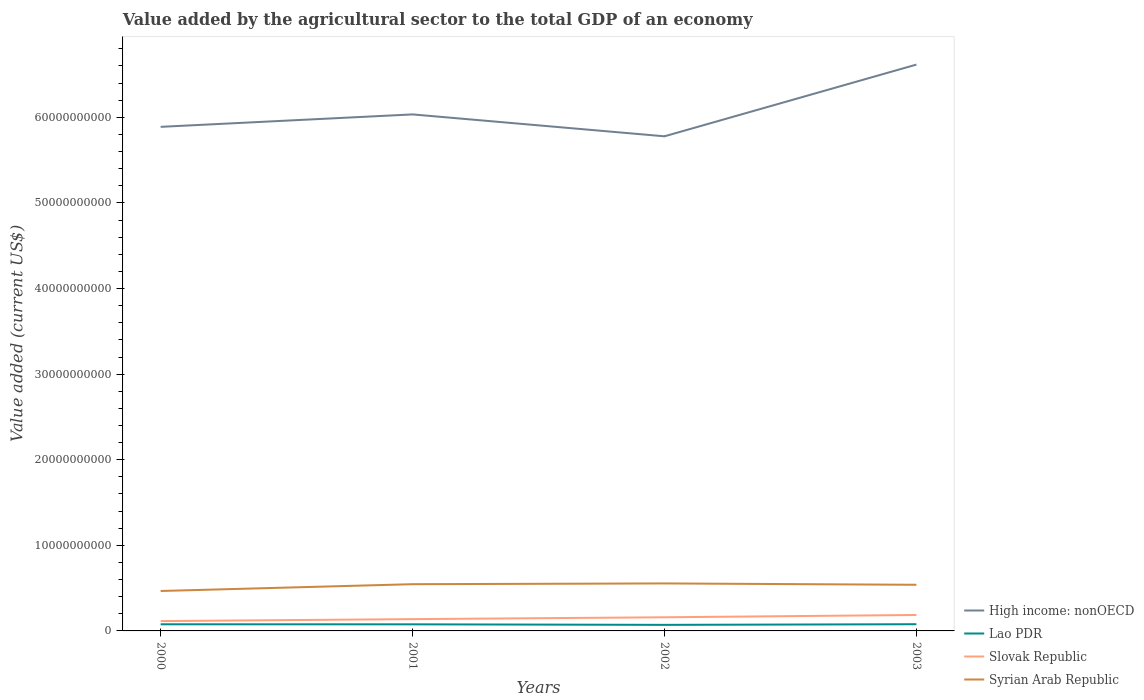Is the number of lines equal to the number of legend labels?
Provide a succinct answer. Yes. Across all years, what is the maximum value added by the agricultural sector to the total GDP in Syrian Arab Republic?
Offer a terse response. 4.67e+09. In which year was the value added by the agricultural sector to the total GDP in Syrian Arab Republic maximum?
Offer a very short reply. 2000. What is the total value added by the agricultural sector to the total GDP in Syrian Arab Republic in the graph?
Your answer should be very brief. -7.94e+08. What is the difference between the highest and the second highest value added by the agricultural sector to the total GDP in Syrian Arab Republic?
Provide a succinct answer. 8.83e+08. How many lines are there?
Offer a very short reply. 4. Does the graph contain any zero values?
Make the answer very short. No. Does the graph contain grids?
Ensure brevity in your answer.  No. Where does the legend appear in the graph?
Give a very brief answer. Bottom right. How are the legend labels stacked?
Give a very brief answer. Vertical. What is the title of the graph?
Provide a succinct answer. Value added by the agricultural sector to the total GDP of an economy. What is the label or title of the X-axis?
Keep it short and to the point. Years. What is the label or title of the Y-axis?
Your answer should be compact. Value added (current US$). What is the Value added (current US$) in High income: nonOECD in 2000?
Make the answer very short. 5.89e+1. What is the Value added (current US$) in Lao PDR in 2000?
Offer a very short reply. 7.76e+08. What is the Value added (current US$) in Slovak Republic in 2000?
Your answer should be very brief. 1.15e+09. What is the Value added (current US$) in Syrian Arab Republic in 2000?
Ensure brevity in your answer.  4.67e+09. What is the Value added (current US$) of High income: nonOECD in 2001?
Offer a very short reply. 6.03e+1. What is the Value added (current US$) of Lao PDR in 2001?
Make the answer very short. 7.70e+08. What is the Value added (current US$) in Slovak Republic in 2001?
Provide a short and direct response. 1.38e+09. What is the Value added (current US$) in Syrian Arab Republic in 2001?
Your response must be concise. 5.46e+09. What is the Value added (current US$) in High income: nonOECD in 2002?
Your answer should be compact. 5.78e+1. What is the Value added (current US$) in Lao PDR in 2002?
Provide a short and direct response. 7.08e+08. What is the Value added (current US$) of Slovak Republic in 2002?
Provide a succinct answer. 1.59e+09. What is the Value added (current US$) of Syrian Arab Republic in 2002?
Provide a short and direct response. 5.55e+09. What is the Value added (current US$) in High income: nonOECD in 2003?
Provide a short and direct response. 6.62e+1. What is the Value added (current US$) in Lao PDR in 2003?
Your answer should be very brief. 7.83e+08. What is the Value added (current US$) of Slovak Republic in 2003?
Offer a very short reply. 1.86e+09. What is the Value added (current US$) in Syrian Arab Republic in 2003?
Your response must be concise. 5.39e+09. Across all years, what is the maximum Value added (current US$) of High income: nonOECD?
Your response must be concise. 6.62e+1. Across all years, what is the maximum Value added (current US$) of Lao PDR?
Give a very brief answer. 7.83e+08. Across all years, what is the maximum Value added (current US$) of Slovak Republic?
Offer a very short reply. 1.86e+09. Across all years, what is the maximum Value added (current US$) in Syrian Arab Republic?
Give a very brief answer. 5.55e+09. Across all years, what is the minimum Value added (current US$) in High income: nonOECD?
Give a very brief answer. 5.78e+1. Across all years, what is the minimum Value added (current US$) of Lao PDR?
Ensure brevity in your answer.  7.08e+08. Across all years, what is the minimum Value added (current US$) of Slovak Republic?
Offer a very short reply. 1.15e+09. Across all years, what is the minimum Value added (current US$) in Syrian Arab Republic?
Provide a succinct answer. 4.67e+09. What is the total Value added (current US$) in High income: nonOECD in the graph?
Make the answer very short. 2.43e+11. What is the total Value added (current US$) of Lao PDR in the graph?
Keep it short and to the point. 3.04e+09. What is the total Value added (current US$) of Slovak Republic in the graph?
Your answer should be compact. 5.98e+09. What is the total Value added (current US$) in Syrian Arab Republic in the graph?
Your response must be concise. 2.11e+1. What is the difference between the Value added (current US$) of High income: nonOECD in 2000 and that in 2001?
Your answer should be compact. -1.45e+09. What is the difference between the Value added (current US$) of Lao PDR in 2000 and that in 2001?
Your answer should be very brief. 5.38e+06. What is the difference between the Value added (current US$) in Slovak Republic in 2000 and that in 2001?
Ensure brevity in your answer.  -2.29e+08. What is the difference between the Value added (current US$) in Syrian Arab Republic in 2000 and that in 2001?
Your answer should be compact. -7.94e+08. What is the difference between the Value added (current US$) in High income: nonOECD in 2000 and that in 2002?
Keep it short and to the point. 1.11e+09. What is the difference between the Value added (current US$) in Lao PDR in 2000 and that in 2002?
Make the answer very short. 6.74e+07. What is the difference between the Value added (current US$) in Slovak Republic in 2000 and that in 2002?
Ensure brevity in your answer.  -4.45e+08. What is the difference between the Value added (current US$) in Syrian Arab Republic in 2000 and that in 2002?
Offer a terse response. -8.83e+08. What is the difference between the Value added (current US$) in High income: nonOECD in 2000 and that in 2003?
Ensure brevity in your answer.  -7.27e+09. What is the difference between the Value added (current US$) in Lao PDR in 2000 and that in 2003?
Provide a short and direct response. -7.64e+06. What is the difference between the Value added (current US$) in Slovak Republic in 2000 and that in 2003?
Your answer should be compact. -7.15e+08. What is the difference between the Value added (current US$) of Syrian Arab Republic in 2000 and that in 2003?
Make the answer very short. -7.24e+08. What is the difference between the Value added (current US$) of High income: nonOECD in 2001 and that in 2002?
Ensure brevity in your answer.  2.56e+09. What is the difference between the Value added (current US$) of Lao PDR in 2001 and that in 2002?
Your answer should be very brief. 6.21e+07. What is the difference between the Value added (current US$) in Slovak Republic in 2001 and that in 2002?
Keep it short and to the point. -2.16e+08. What is the difference between the Value added (current US$) in Syrian Arab Republic in 2001 and that in 2002?
Keep it short and to the point. -8.88e+07. What is the difference between the Value added (current US$) in High income: nonOECD in 2001 and that in 2003?
Your response must be concise. -5.82e+09. What is the difference between the Value added (current US$) of Lao PDR in 2001 and that in 2003?
Provide a short and direct response. -1.30e+07. What is the difference between the Value added (current US$) in Slovak Republic in 2001 and that in 2003?
Your answer should be very brief. -4.86e+08. What is the difference between the Value added (current US$) of Syrian Arab Republic in 2001 and that in 2003?
Ensure brevity in your answer.  6.96e+07. What is the difference between the Value added (current US$) of High income: nonOECD in 2002 and that in 2003?
Offer a very short reply. -8.38e+09. What is the difference between the Value added (current US$) in Lao PDR in 2002 and that in 2003?
Provide a short and direct response. -7.51e+07. What is the difference between the Value added (current US$) of Slovak Republic in 2002 and that in 2003?
Offer a very short reply. -2.71e+08. What is the difference between the Value added (current US$) of Syrian Arab Republic in 2002 and that in 2003?
Your response must be concise. 1.58e+08. What is the difference between the Value added (current US$) of High income: nonOECD in 2000 and the Value added (current US$) of Lao PDR in 2001?
Give a very brief answer. 5.81e+1. What is the difference between the Value added (current US$) in High income: nonOECD in 2000 and the Value added (current US$) in Slovak Republic in 2001?
Keep it short and to the point. 5.75e+1. What is the difference between the Value added (current US$) of High income: nonOECD in 2000 and the Value added (current US$) of Syrian Arab Republic in 2001?
Your answer should be compact. 5.34e+1. What is the difference between the Value added (current US$) of Lao PDR in 2000 and the Value added (current US$) of Slovak Republic in 2001?
Ensure brevity in your answer.  -6.02e+08. What is the difference between the Value added (current US$) in Lao PDR in 2000 and the Value added (current US$) in Syrian Arab Republic in 2001?
Your response must be concise. -4.68e+09. What is the difference between the Value added (current US$) in Slovak Republic in 2000 and the Value added (current US$) in Syrian Arab Republic in 2001?
Provide a succinct answer. -4.31e+09. What is the difference between the Value added (current US$) in High income: nonOECD in 2000 and the Value added (current US$) in Lao PDR in 2002?
Your answer should be very brief. 5.82e+1. What is the difference between the Value added (current US$) in High income: nonOECD in 2000 and the Value added (current US$) in Slovak Republic in 2002?
Keep it short and to the point. 5.73e+1. What is the difference between the Value added (current US$) of High income: nonOECD in 2000 and the Value added (current US$) of Syrian Arab Republic in 2002?
Keep it short and to the point. 5.33e+1. What is the difference between the Value added (current US$) of Lao PDR in 2000 and the Value added (current US$) of Slovak Republic in 2002?
Provide a short and direct response. -8.17e+08. What is the difference between the Value added (current US$) in Lao PDR in 2000 and the Value added (current US$) in Syrian Arab Republic in 2002?
Your answer should be very brief. -4.77e+09. What is the difference between the Value added (current US$) of Slovak Republic in 2000 and the Value added (current US$) of Syrian Arab Republic in 2002?
Provide a short and direct response. -4.40e+09. What is the difference between the Value added (current US$) in High income: nonOECD in 2000 and the Value added (current US$) in Lao PDR in 2003?
Give a very brief answer. 5.81e+1. What is the difference between the Value added (current US$) in High income: nonOECD in 2000 and the Value added (current US$) in Slovak Republic in 2003?
Make the answer very short. 5.70e+1. What is the difference between the Value added (current US$) of High income: nonOECD in 2000 and the Value added (current US$) of Syrian Arab Republic in 2003?
Make the answer very short. 5.35e+1. What is the difference between the Value added (current US$) of Lao PDR in 2000 and the Value added (current US$) of Slovak Republic in 2003?
Your response must be concise. -1.09e+09. What is the difference between the Value added (current US$) in Lao PDR in 2000 and the Value added (current US$) in Syrian Arab Republic in 2003?
Offer a very short reply. -4.61e+09. What is the difference between the Value added (current US$) in Slovak Republic in 2000 and the Value added (current US$) in Syrian Arab Republic in 2003?
Make the answer very short. -4.24e+09. What is the difference between the Value added (current US$) in High income: nonOECD in 2001 and the Value added (current US$) in Lao PDR in 2002?
Provide a succinct answer. 5.96e+1. What is the difference between the Value added (current US$) of High income: nonOECD in 2001 and the Value added (current US$) of Slovak Republic in 2002?
Give a very brief answer. 5.87e+1. What is the difference between the Value added (current US$) of High income: nonOECD in 2001 and the Value added (current US$) of Syrian Arab Republic in 2002?
Make the answer very short. 5.48e+1. What is the difference between the Value added (current US$) of Lao PDR in 2001 and the Value added (current US$) of Slovak Republic in 2002?
Provide a succinct answer. -8.23e+08. What is the difference between the Value added (current US$) of Lao PDR in 2001 and the Value added (current US$) of Syrian Arab Republic in 2002?
Give a very brief answer. -4.78e+09. What is the difference between the Value added (current US$) in Slovak Republic in 2001 and the Value added (current US$) in Syrian Arab Republic in 2002?
Your answer should be compact. -4.17e+09. What is the difference between the Value added (current US$) in High income: nonOECD in 2001 and the Value added (current US$) in Lao PDR in 2003?
Offer a very short reply. 5.96e+1. What is the difference between the Value added (current US$) of High income: nonOECD in 2001 and the Value added (current US$) of Slovak Republic in 2003?
Give a very brief answer. 5.85e+1. What is the difference between the Value added (current US$) of High income: nonOECD in 2001 and the Value added (current US$) of Syrian Arab Republic in 2003?
Your answer should be compact. 5.50e+1. What is the difference between the Value added (current US$) in Lao PDR in 2001 and the Value added (current US$) in Slovak Republic in 2003?
Offer a terse response. -1.09e+09. What is the difference between the Value added (current US$) in Lao PDR in 2001 and the Value added (current US$) in Syrian Arab Republic in 2003?
Your answer should be compact. -4.62e+09. What is the difference between the Value added (current US$) of Slovak Republic in 2001 and the Value added (current US$) of Syrian Arab Republic in 2003?
Your answer should be very brief. -4.01e+09. What is the difference between the Value added (current US$) of High income: nonOECD in 2002 and the Value added (current US$) of Lao PDR in 2003?
Provide a succinct answer. 5.70e+1. What is the difference between the Value added (current US$) in High income: nonOECD in 2002 and the Value added (current US$) in Slovak Republic in 2003?
Give a very brief answer. 5.59e+1. What is the difference between the Value added (current US$) in High income: nonOECD in 2002 and the Value added (current US$) in Syrian Arab Republic in 2003?
Provide a succinct answer. 5.24e+1. What is the difference between the Value added (current US$) of Lao PDR in 2002 and the Value added (current US$) of Slovak Republic in 2003?
Keep it short and to the point. -1.16e+09. What is the difference between the Value added (current US$) in Lao PDR in 2002 and the Value added (current US$) in Syrian Arab Republic in 2003?
Give a very brief answer. -4.68e+09. What is the difference between the Value added (current US$) in Slovak Republic in 2002 and the Value added (current US$) in Syrian Arab Republic in 2003?
Offer a very short reply. -3.80e+09. What is the average Value added (current US$) of High income: nonOECD per year?
Your answer should be very brief. 6.08e+1. What is the average Value added (current US$) in Lao PDR per year?
Offer a terse response. 7.60e+08. What is the average Value added (current US$) of Slovak Republic per year?
Offer a terse response. 1.50e+09. What is the average Value added (current US$) of Syrian Arab Republic per year?
Your answer should be very brief. 5.27e+09. In the year 2000, what is the difference between the Value added (current US$) of High income: nonOECD and Value added (current US$) of Lao PDR?
Give a very brief answer. 5.81e+1. In the year 2000, what is the difference between the Value added (current US$) in High income: nonOECD and Value added (current US$) in Slovak Republic?
Offer a very short reply. 5.77e+1. In the year 2000, what is the difference between the Value added (current US$) in High income: nonOECD and Value added (current US$) in Syrian Arab Republic?
Provide a short and direct response. 5.42e+1. In the year 2000, what is the difference between the Value added (current US$) in Lao PDR and Value added (current US$) in Slovak Republic?
Give a very brief answer. -3.73e+08. In the year 2000, what is the difference between the Value added (current US$) in Lao PDR and Value added (current US$) in Syrian Arab Republic?
Keep it short and to the point. -3.89e+09. In the year 2000, what is the difference between the Value added (current US$) of Slovak Republic and Value added (current US$) of Syrian Arab Republic?
Make the answer very short. -3.52e+09. In the year 2001, what is the difference between the Value added (current US$) in High income: nonOECD and Value added (current US$) in Lao PDR?
Offer a very short reply. 5.96e+1. In the year 2001, what is the difference between the Value added (current US$) of High income: nonOECD and Value added (current US$) of Slovak Republic?
Your answer should be compact. 5.90e+1. In the year 2001, what is the difference between the Value added (current US$) in High income: nonOECD and Value added (current US$) in Syrian Arab Republic?
Your response must be concise. 5.49e+1. In the year 2001, what is the difference between the Value added (current US$) in Lao PDR and Value added (current US$) in Slovak Republic?
Provide a succinct answer. -6.07e+08. In the year 2001, what is the difference between the Value added (current US$) in Lao PDR and Value added (current US$) in Syrian Arab Republic?
Your answer should be compact. -4.69e+09. In the year 2001, what is the difference between the Value added (current US$) of Slovak Republic and Value added (current US$) of Syrian Arab Republic?
Provide a succinct answer. -4.08e+09. In the year 2002, what is the difference between the Value added (current US$) in High income: nonOECD and Value added (current US$) in Lao PDR?
Offer a very short reply. 5.71e+1. In the year 2002, what is the difference between the Value added (current US$) of High income: nonOECD and Value added (current US$) of Slovak Republic?
Your response must be concise. 5.62e+1. In the year 2002, what is the difference between the Value added (current US$) of High income: nonOECD and Value added (current US$) of Syrian Arab Republic?
Provide a short and direct response. 5.22e+1. In the year 2002, what is the difference between the Value added (current US$) of Lao PDR and Value added (current US$) of Slovak Republic?
Keep it short and to the point. -8.85e+08. In the year 2002, what is the difference between the Value added (current US$) of Lao PDR and Value added (current US$) of Syrian Arab Republic?
Provide a short and direct response. -4.84e+09. In the year 2002, what is the difference between the Value added (current US$) in Slovak Republic and Value added (current US$) in Syrian Arab Republic?
Offer a terse response. -3.96e+09. In the year 2003, what is the difference between the Value added (current US$) in High income: nonOECD and Value added (current US$) in Lao PDR?
Offer a terse response. 6.54e+1. In the year 2003, what is the difference between the Value added (current US$) of High income: nonOECD and Value added (current US$) of Slovak Republic?
Provide a succinct answer. 6.43e+1. In the year 2003, what is the difference between the Value added (current US$) of High income: nonOECD and Value added (current US$) of Syrian Arab Republic?
Make the answer very short. 6.08e+1. In the year 2003, what is the difference between the Value added (current US$) of Lao PDR and Value added (current US$) of Slovak Republic?
Give a very brief answer. -1.08e+09. In the year 2003, what is the difference between the Value added (current US$) of Lao PDR and Value added (current US$) of Syrian Arab Republic?
Provide a short and direct response. -4.61e+09. In the year 2003, what is the difference between the Value added (current US$) in Slovak Republic and Value added (current US$) in Syrian Arab Republic?
Your answer should be very brief. -3.53e+09. What is the ratio of the Value added (current US$) of High income: nonOECD in 2000 to that in 2001?
Ensure brevity in your answer.  0.98. What is the ratio of the Value added (current US$) of Slovak Republic in 2000 to that in 2001?
Ensure brevity in your answer.  0.83. What is the ratio of the Value added (current US$) of Syrian Arab Republic in 2000 to that in 2001?
Make the answer very short. 0.85. What is the ratio of the Value added (current US$) in High income: nonOECD in 2000 to that in 2002?
Keep it short and to the point. 1.02. What is the ratio of the Value added (current US$) of Lao PDR in 2000 to that in 2002?
Offer a very short reply. 1.1. What is the ratio of the Value added (current US$) of Slovak Republic in 2000 to that in 2002?
Your answer should be very brief. 0.72. What is the ratio of the Value added (current US$) of Syrian Arab Republic in 2000 to that in 2002?
Give a very brief answer. 0.84. What is the ratio of the Value added (current US$) of High income: nonOECD in 2000 to that in 2003?
Your response must be concise. 0.89. What is the ratio of the Value added (current US$) in Lao PDR in 2000 to that in 2003?
Give a very brief answer. 0.99. What is the ratio of the Value added (current US$) in Slovak Republic in 2000 to that in 2003?
Offer a terse response. 0.62. What is the ratio of the Value added (current US$) of Syrian Arab Republic in 2000 to that in 2003?
Make the answer very short. 0.87. What is the ratio of the Value added (current US$) in High income: nonOECD in 2001 to that in 2002?
Offer a very short reply. 1.04. What is the ratio of the Value added (current US$) of Lao PDR in 2001 to that in 2002?
Your response must be concise. 1.09. What is the ratio of the Value added (current US$) of Slovak Republic in 2001 to that in 2002?
Provide a short and direct response. 0.86. What is the ratio of the Value added (current US$) in High income: nonOECD in 2001 to that in 2003?
Give a very brief answer. 0.91. What is the ratio of the Value added (current US$) in Lao PDR in 2001 to that in 2003?
Your answer should be very brief. 0.98. What is the ratio of the Value added (current US$) of Slovak Republic in 2001 to that in 2003?
Your answer should be compact. 0.74. What is the ratio of the Value added (current US$) of Syrian Arab Republic in 2001 to that in 2003?
Make the answer very short. 1.01. What is the ratio of the Value added (current US$) in High income: nonOECD in 2002 to that in 2003?
Ensure brevity in your answer.  0.87. What is the ratio of the Value added (current US$) of Lao PDR in 2002 to that in 2003?
Keep it short and to the point. 0.9. What is the ratio of the Value added (current US$) of Slovak Republic in 2002 to that in 2003?
Your answer should be very brief. 0.85. What is the ratio of the Value added (current US$) in Syrian Arab Republic in 2002 to that in 2003?
Provide a succinct answer. 1.03. What is the difference between the highest and the second highest Value added (current US$) in High income: nonOECD?
Give a very brief answer. 5.82e+09. What is the difference between the highest and the second highest Value added (current US$) in Lao PDR?
Your response must be concise. 7.64e+06. What is the difference between the highest and the second highest Value added (current US$) of Slovak Republic?
Your answer should be compact. 2.71e+08. What is the difference between the highest and the second highest Value added (current US$) in Syrian Arab Republic?
Ensure brevity in your answer.  8.88e+07. What is the difference between the highest and the lowest Value added (current US$) in High income: nonOECD?
Provide a succinct answer. 8.38e+09. What is the difference between the highest and the lowest Value added (current US$) in Lao PDR?
Provide a succinct answer. 7.51e+07. What is the difference between the highest and the lowest Value added (current US$) in Slovak Republic?
Provide a succinct answer. 7.15e+08. What is the difference between the highest and the lowest Value added (current US$) of Syrian Arab Republic?
Provide a succinct answer. 8.83e+08. 